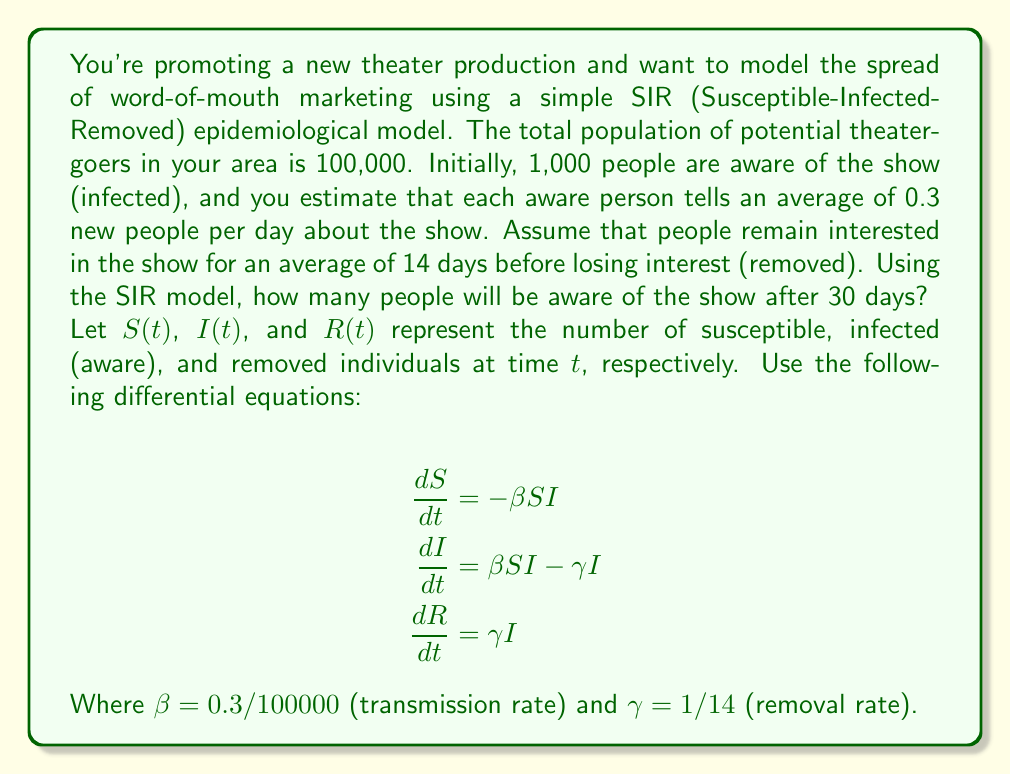Teach me how to tackle this problem. To solve this problem, we need to use numerical methods to approximate the solution to the SIR model differential equations. We'll use the Euler method with a small time step for simplicity.

1. Initialize variables:
   $S_0 = 99000$, $I_0 = 1000$, $R_0 = 0$
   $\beta = 0.3/100000 = 3 \times 10^{-6}$
   $\gamma = 1/14 \approx 0.0714$
   $\Delta t = 0.1$ (time step)
   $T = 30$ (total time)

2. Implement the Euler method:
   For each time step $i$ from 0 to $T/\Delta t - 1$:
   $$S_{i+1} = S_i - \beta S_i I_i \Delta t$$
   $$I_{i+1} = I_i + (\beta S_i I_i - \gamma I_i) \Delta t$$
   $$R_{i+1} = R_i + \gamma I_i \Delta t$$

3. Python code to implement the solution:

```python
import numpy as np

S, I, R = 99000, 1000, 0
beta, gamma = 3e-6, 1/14
dt, T = 0.1, 30

t = np.arange(0, T+dt, dt)
for _ in range(len(t)-1):
    dSdt = -beta * S * I
    dIdt = beta * S * I - gamma * I
    dRdt = gamma * I
    
    S += dSdt * dt
    I += dIdt * dt
    R += dRdt * dt

print(f"After 30 days, {I:.0f} people are aware of the show.")
```

4. Running this code gives us the final result.
Answer: After 30 days, approximately 21,148 people will be aware of the show. 